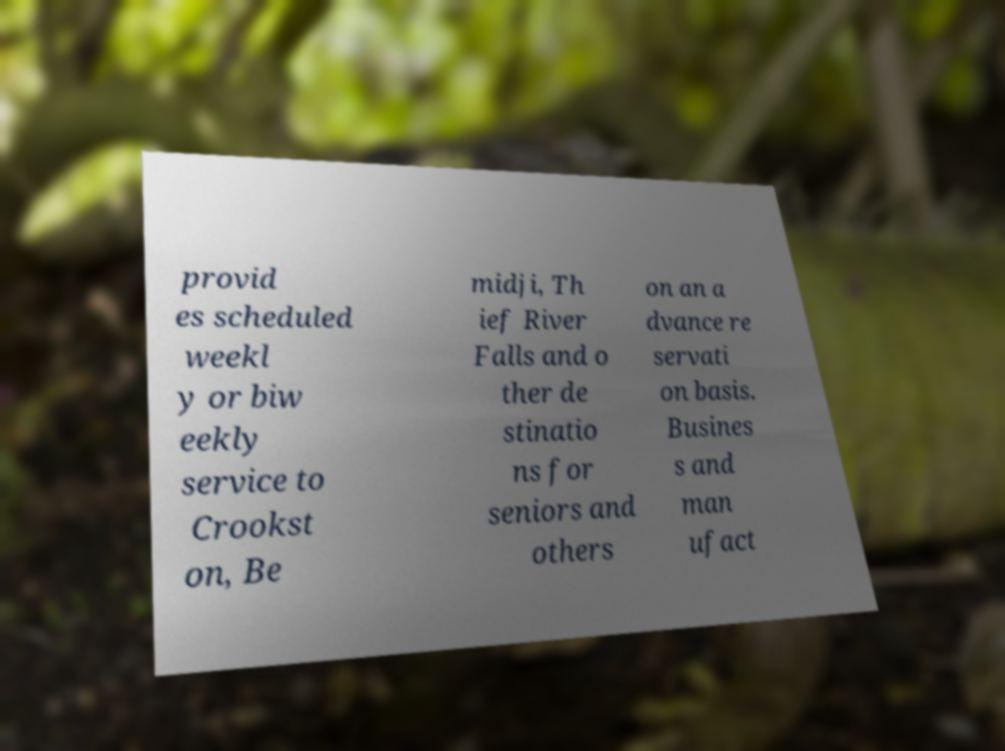What messages or text are displayed in this image? I need them in a readable, typed format. provid es scheduled weekl y or biw eekly service to Crookst on, Be midji, Th ief River Falls and o ther de stinatio ns for seniors and others on an a dvance re servati on basis. Busines s and man ufact 